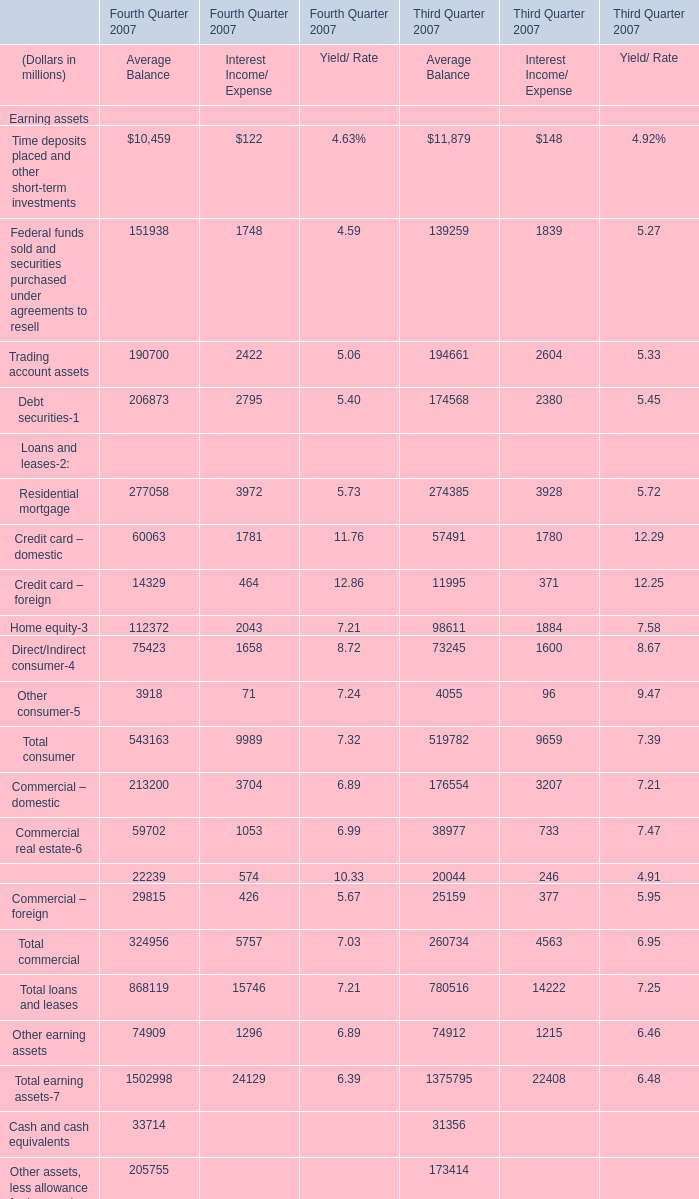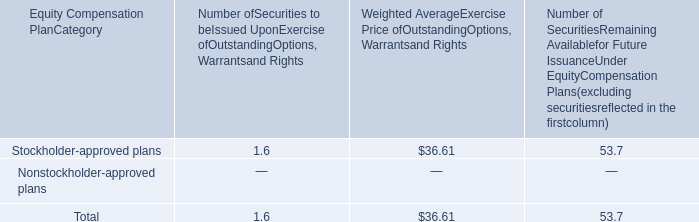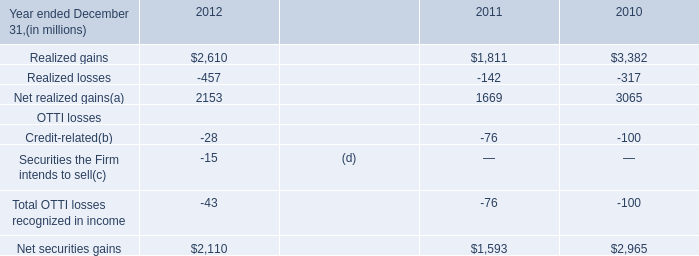what's the total amount of Net realized gains of 2010, and Commercial – domestic of Third Quarter 2007 Average Balance ? 
Computations: (3065.0 + 176554.0)
Answer: 179619.0. 